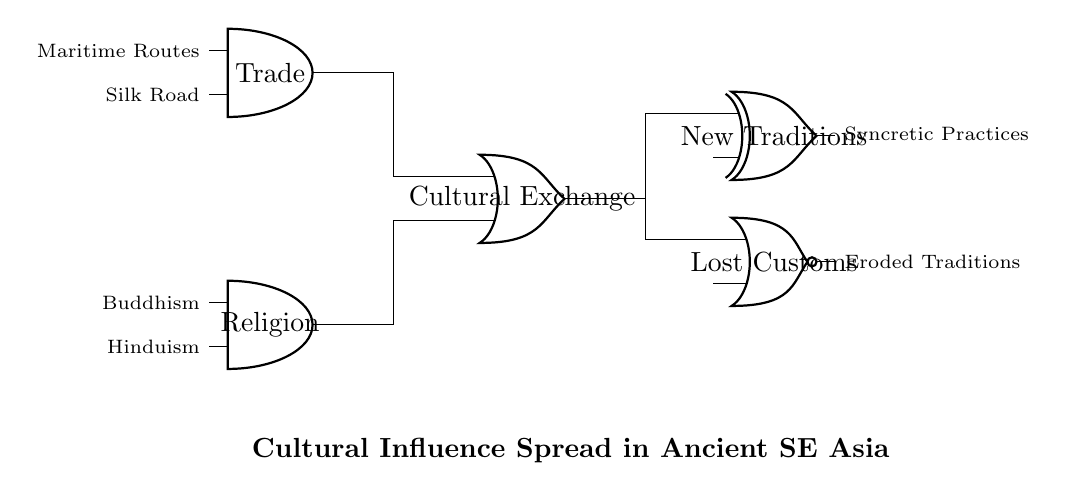What are the inputs to the AND gates? The inputs to the AND gates are "Maritime Routes" and "Silk Road" for the first AND gate, and "Buddhism" and "Hinduism" for the second AND gate. This can be directly observed from the labels on the input lines connected to the AND gates in the circuit diagram.
Answer: Maritime Routes, Silk Road; Buddhism, Hinduism What is the output of the OR gate? The output of the OR gate is "Cultural Exchange." This is indicated by the label on the output line of the OR gate in the diagram, which takes inputs from both AND gates.
Answer: Cultural Exchange What happens to the "Cultural Exchange" signal? The "Cultural Exchange" signal is combined to produce two outputs: "New Traditions" and "Lost Customs." The OR gate sends its output to both the XOR gate (for New Traditions) and the NOR gate (for Lost Customs), as shown in the connections.
Answer: Produces New Traditions and Lost Customs Which gate is used to represent the introduction of New Traditions? The XOR gate represents the introduction of New Traditions in this circuit. The output from the OR gate connects to the XOR gate, indicating that the combination of cultural influences may lead to new traditions.
Answer: XOR gate What is the significance of the NOR gate in this circuit? The NOR gate is significant as it represents the concept of "Lost Customs," indicating that despite cultural exchanges, some traditions may be eroded or lost. This reflects the potential negative outcome of cultural influences.
Answer: Lost Customs 